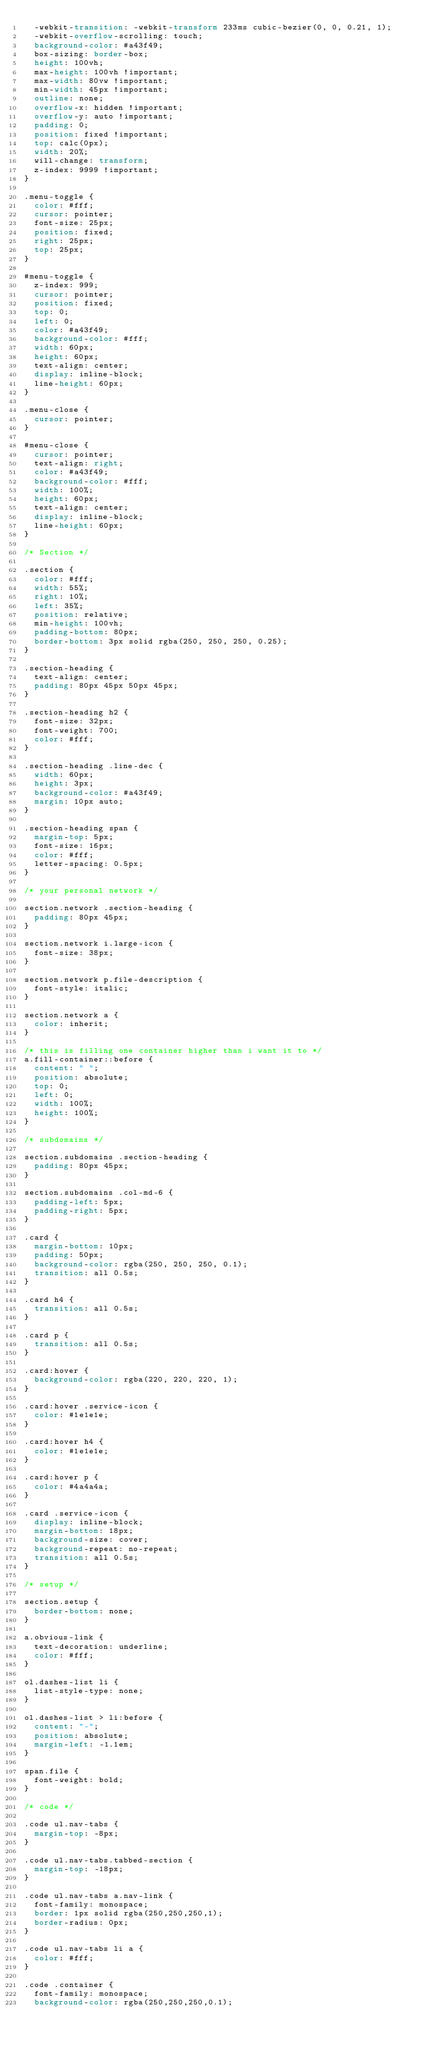<code> <loc_0><loc_0><loc_500><loc_500><_CSS_>  -webkit-transition: -webkit-transform 233ms cubic-bezier(0, 0, 0.21, 1);
  -webkit-overflow-scrolling: touch;
  background-color: #a43f49;
  box-sizing: border-box;
  height: 100vh;  
  max-height: 100vh !important;
  max-width: 80vw !important;
  min-width: 45px !important;
  outline: none;
  overflow-x: hidden !important;
  overflow-y: auto !important;
  padding: 0;
  position: fixed !important;
  top: calc(0px);  
  width: 20%;
  will-change: transform;
  z-index: 9999 !important;
}

.menu-toggle {
  color: #fff;
  cursor: pointer;
  font-size: 25px;
  position: fixed;
  right: 25px;
  top: 25px;
}

#menu-toggle {
  z-index: 999;
  cursor: pointer;
  position: fixed;
  top: 0;
  left: 0;
  color: #a43f49;
  background-color: #fff;
  width: 60px;
  height: 60px;
  text-align: center;
  display: inline-block;
  line-height: 60px;
}

.menu-close {
  cursor: pointer;
}

#menu-close {
  cursor: pointer;
  text-align: right;
  color: #a43f49;
  background-color: #fff;
  width: 100%;
  height: 60px;
  text-align: center;
  display: inline-block;
  line-height: 60px;
}

/* Section */

.section {
  color: #fff;
  width: 55%;
  right: 10%;
  left: 35%;
  position: relative;
  min-height: 100vh;
  padding-bottom: 80px;
  border-bottom: 3px solid rgba(250, 250, 250, 0.25);
}

.section-heading {
  text-align: center;
  padding: 80px 45px 50px 45px;
}

.section-heading h2 {
  font-size: 32px;
  font-weight: 700;
  color: #fff;
}

.section-heading .line-dec {
  width: 60px;
  height: 3px;
  background-color: #a43f49;
  margin: 10px auto;
}

.section-heading span {
  margin-top: 5px;
  font-size: 16px;
  color: #fff;
  letter-spacing: 0.5px;
}

/* your personal network */

section.network .section-heading {
  padding: 80px 45px;
}

section.network i.large-icon {
  font-size: 38px;
}

section.network p.file-description {
  font-style: italic;
}

section.network a {
  color: inherit;
}

/* this is filling one container higher than i want it to */
a.fill-container::before {
  content: " ";
  position: absolute;
  top: 0;
  left: 0;
  width: 100%;
  height: 100%;
}

/* subdomains */

section.subdomains .section-heading {
  padding: 80px 45px;
}

section.subdomains .col-md-6 {
  padding-left: 5px;
  padding-right: 5px;
}

.card {
  margin-bottom: 10px;
  padding: 50px;
  background-color: rgba(250, 250, 250, 0.1);
  transition: all 0.5s;
}

.card h4 {
  transition: all 0.5s;
}

.card p {
  transition: all 0.5s;
}

.card:hover {
  background-color: rgba(220, 220, 220, 1);
}

.card:hover .service-icon {
  color: #1e1e1e;
}

.card:hover h4 {
  color: #1e1e1e;
}

.card:hover p {
  color: #4a4a4a;
}

.card .service-icon {
  display: inline-block;
  margin-bottom: 18px;
  background-size: cover;
  background-repeat: no-repeat;
  transition: all 0.5s;
}

/* setup */

section.setup {
  border-bottom: none;
}

a.obvious-link {
  text-decoration: underline;
  color: #fff;
}

ol.dashes-list li {
  list-style-type: none;
}

ol.dashes-list > li:before {
  content: "-";
  position: absolute;
  margin-left: -1.1em; 
}

span.file {
  font-weight: bold;
}

/* code */

.code ul.nav-tabs {
  margin-top: -8px;
}

.code ul.nav-tabs.tabbed-section {
  margin-top: -18px;
}

.code ul.nav-tabs a.nav-link {
  font-family: monospace;
  border: 1px solid rgba(250,250,250,1);
  border-radius: 0px;
}

.code ul.nav-tabs li a {
  color: #fff;
}

.code .container {
  font-family: monospace;
  background-color: rgba(250,250,250,0.1);</code> 